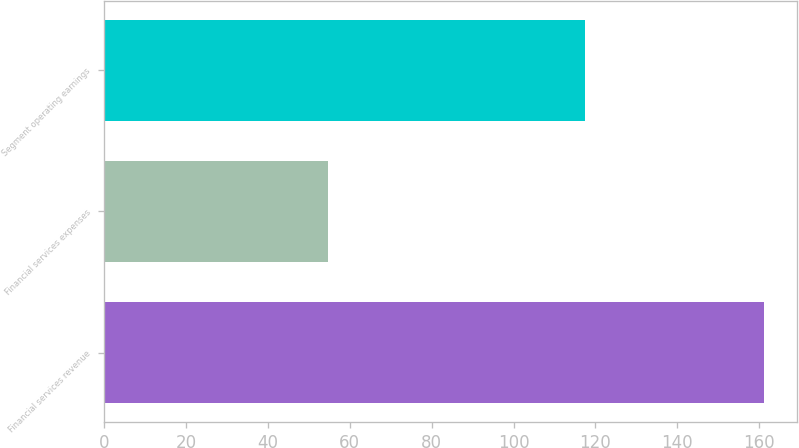<chart> <loc_0><loc_0><loc_500><loc_500><bar_chart><fcel>Financial services revenue<fcel>Financial services expenses<fcel>Segment operating earnings<nl><fcel>161.3<fcel>54.6<fcel>117.37<nl></chart> 